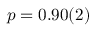Convert formula to latex. <formula><loc_0><loc_0><loc_500><loc_500>p = 0 . 9 0 ( 2 )</formula> 